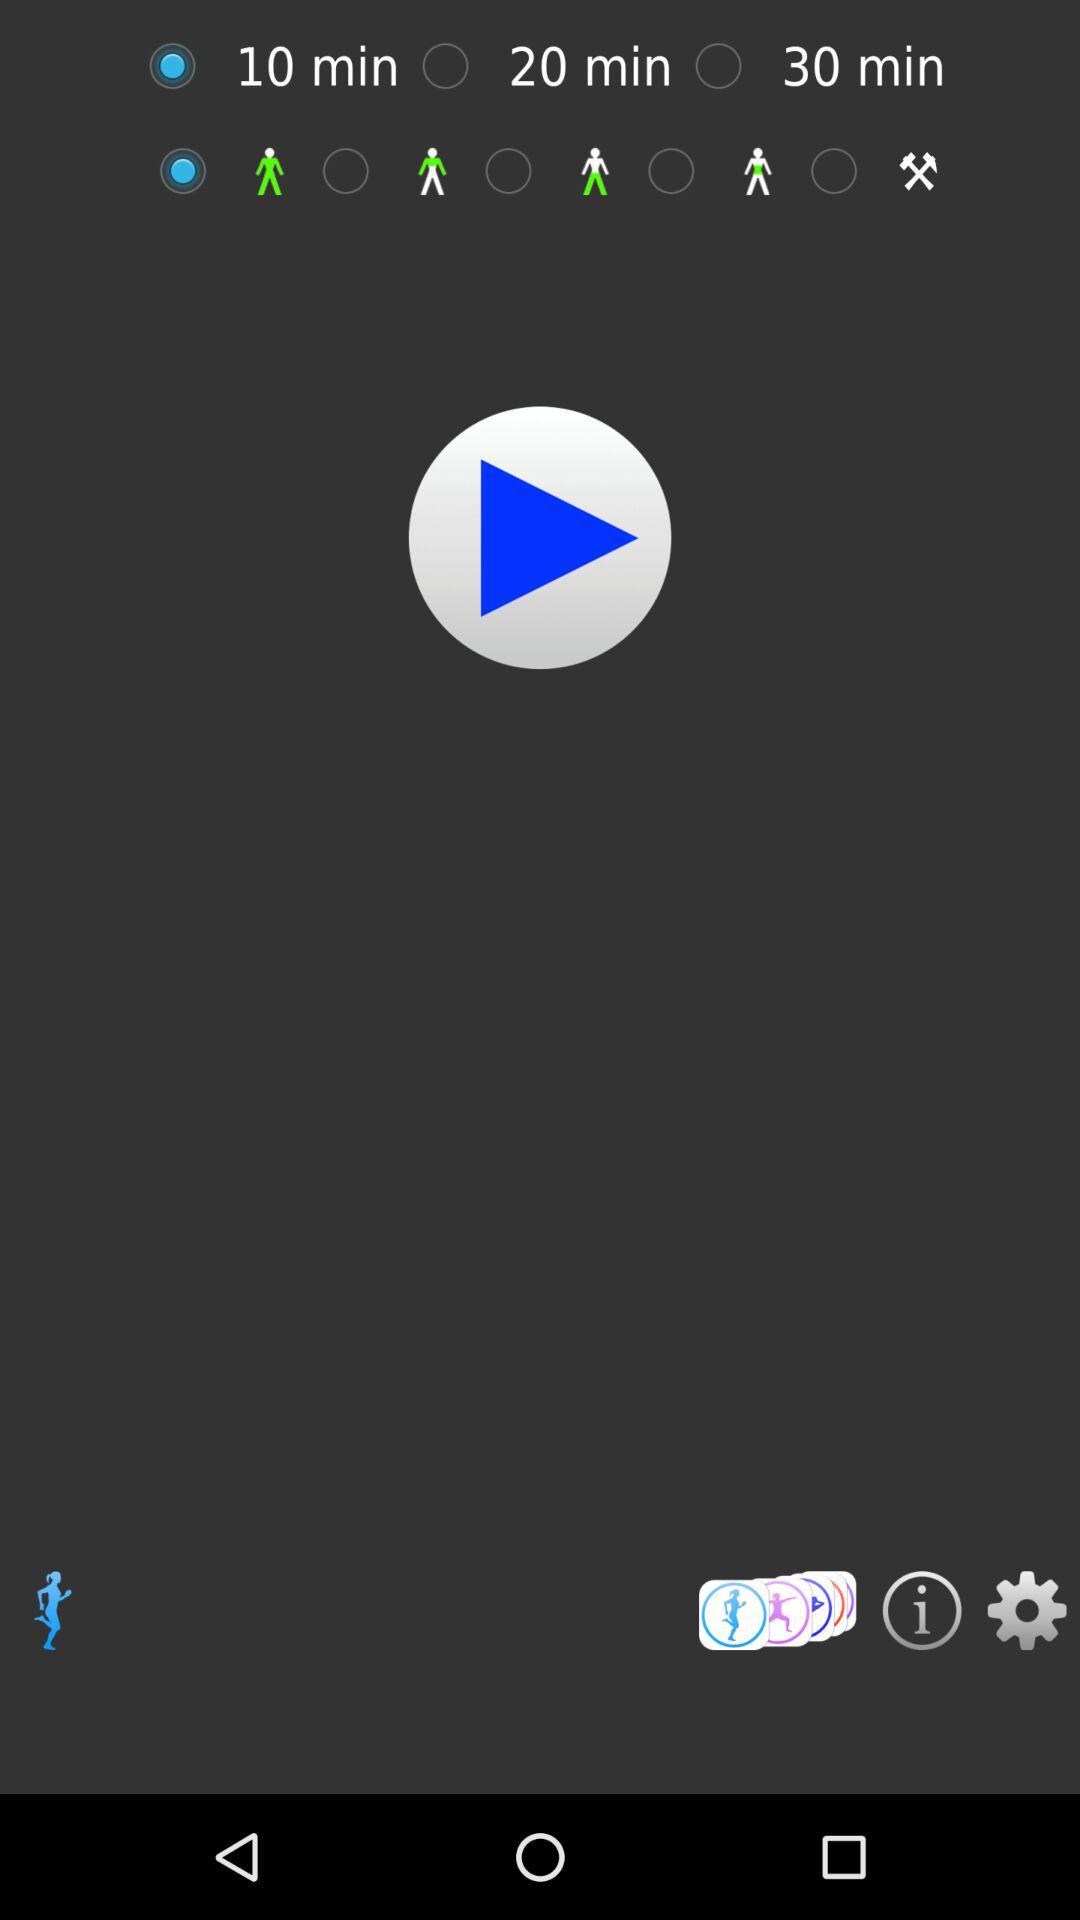How many minutes are selected? There are 10 minutes selected. 